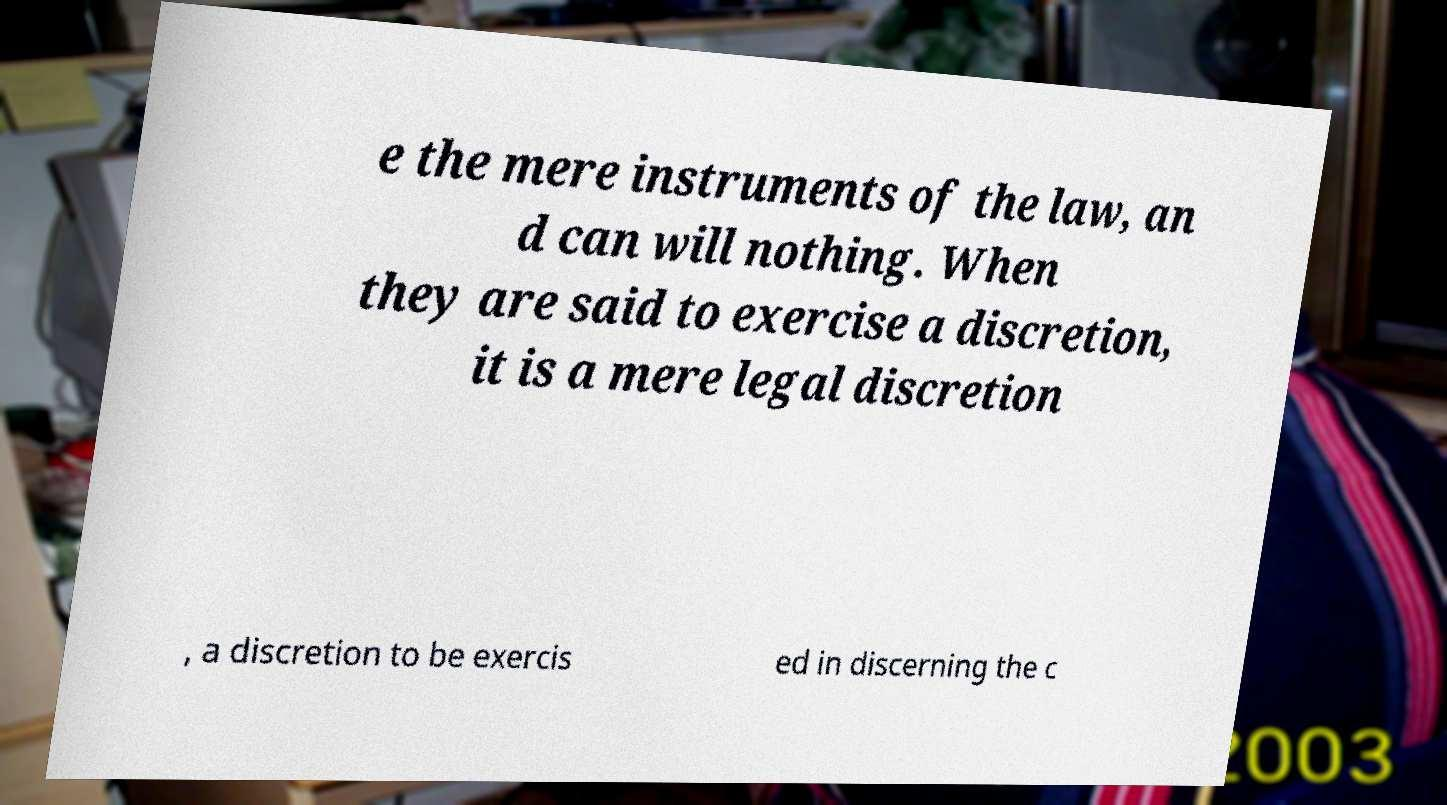What messages or text are displayed in this image? I need them in a readable, typed format. e the mere instruments of the law, an d can will nothing. When they are said to exercise a discretion, it is a mere legal discretion , a discretion to be exercis ed in discerning the c 